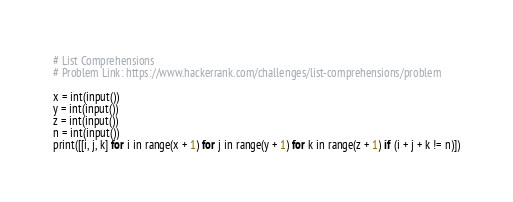Convert code to text. <code><loc_0><loc_0><loc_500><loc_500><_Python_># List Comprehensions
# Problem Link: https://www.hackerrank.com/challenges/list-comprehensions/problem

x = int(input())
y = int(input())
z = int(input())
n = int(input())
print([[i, j, k] for i in range(x + 1) for j in range(y + 1) for k in range(z + 1) if (i + j + k != n)])
</code> 